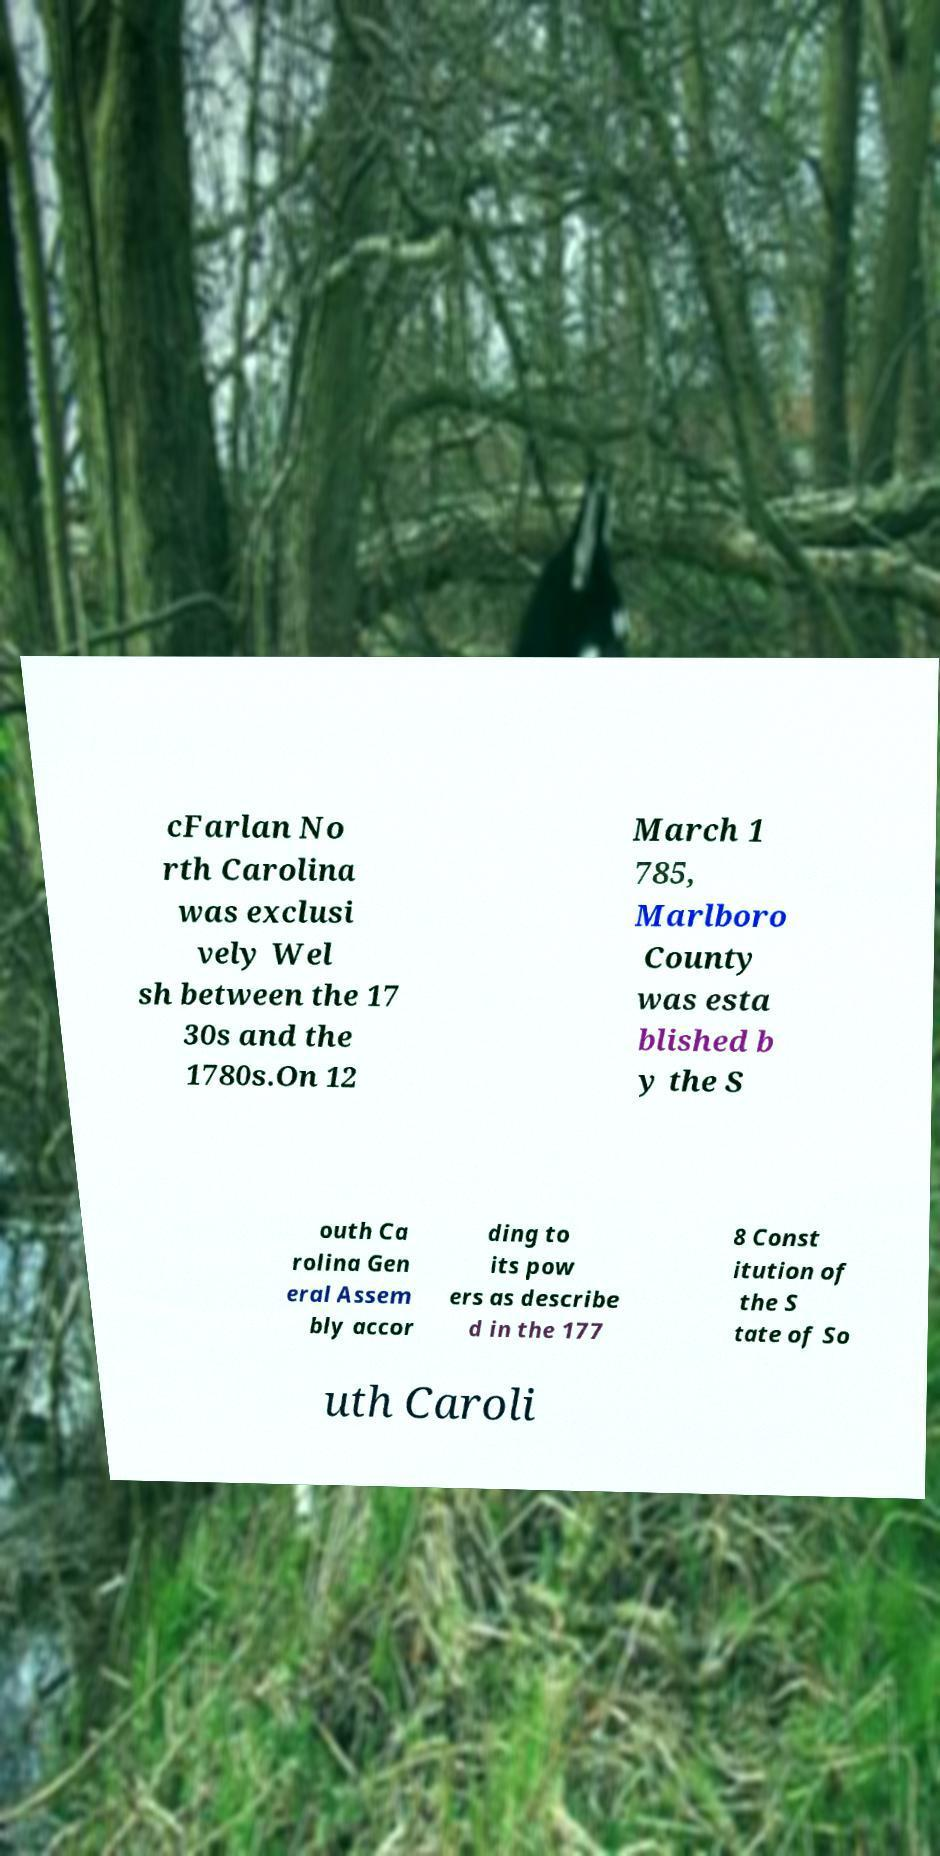There's text embedded in this image that I need extracted. Can you transcribe it verbatim? cFarlan No rth Carolina was exclusi vely Wel sh between the 17 30s and the 1780s.On 12 March 1 785, Marlboro County was esta blished b y the S outh Ca rolina Gen eral Assem bly accor ding to its pow ers as describe d in the 177 8 Const itution of the S tate of So uth Caroli 